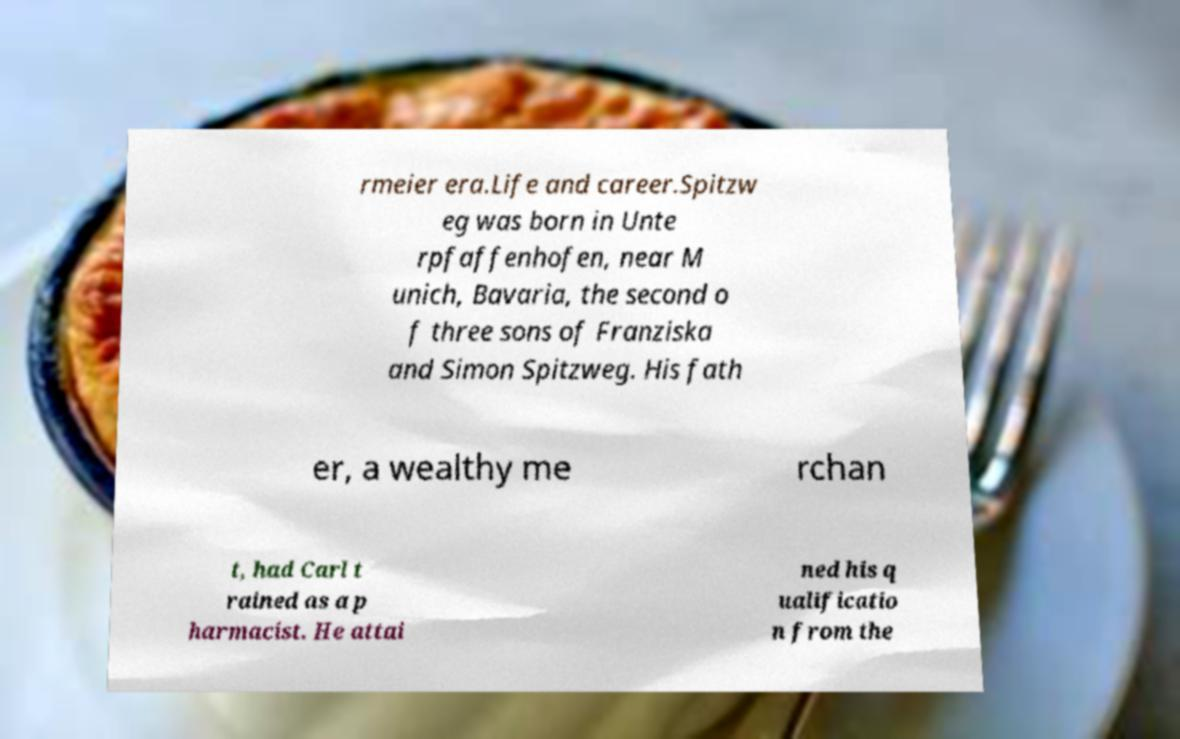There's text embedded in this image that I need extracted. Can you transcribe it verbatim? rmeier era.Life and career.Spitzw eg was born in Unte rpfaffenhofen, near M unich, Bavaria, the second o f three sons of Franziska and Simon Spitzweg. His fath er, a wealthy me rchan t, had Carl t rained as a p harmacist. He attai ned his q ualificatio n from the 